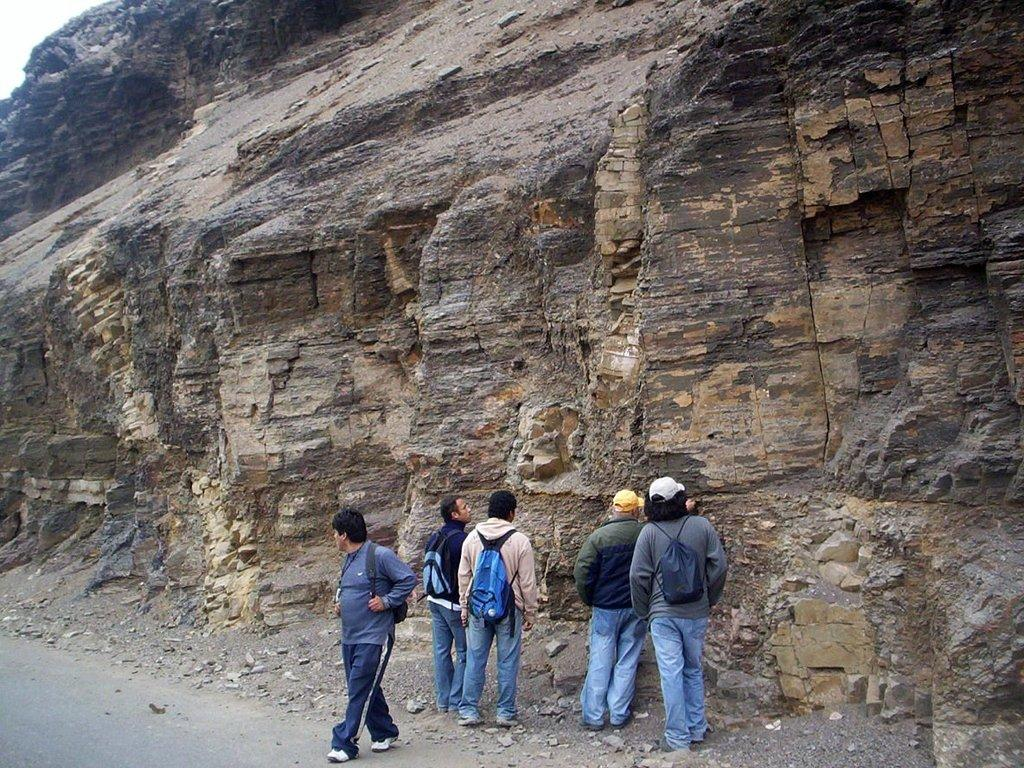How many people are in the image? There are people in the image, but the exact number is not specified. What type of clothing are the people wearing on their upper bodies? The people are wearing T-shirts in the image. What accessories are the people carrying on their backs? The people are wearing backpacks in the image. What type of footwear are the people wearing? The people are wearing shoes in the image. What type of terrain can be seen in the background of the image? There are rock hills visible in the background of the image. What type of milk is being poured into the train in the image? There is no mention of milk or a train in the image. 